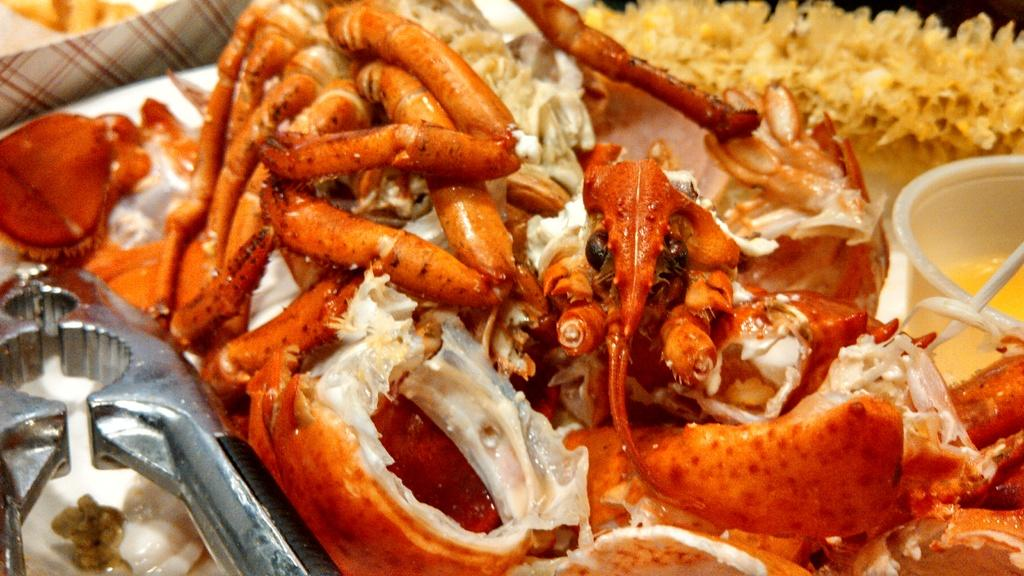What type of food can be seen in the image? There is food in the image, but the specific type is not mentioned. What is the food placed in? The food is placed in a bowl in the image. What material is the bowl made of? The bowl is made of metal. How are the food, bowl, and metal object arranged in the image? All of these objects are in a plate. How does the shelf in the image contribute to the quiet atmosphere? There is no shelf present in the image, so it cannot contribute to the atmosphere. 